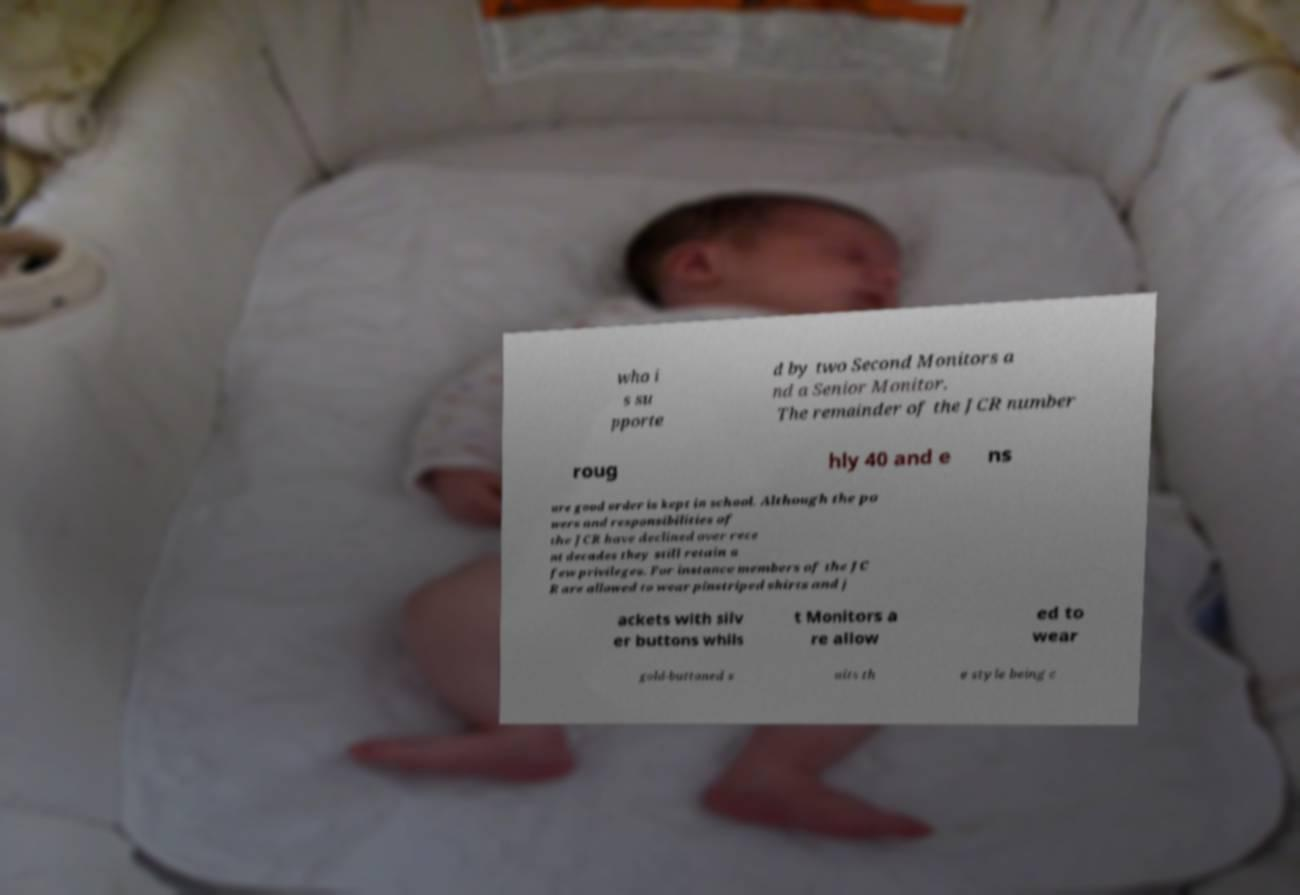What messages or text are displayed in this image? I need them in a readable, typed format. who i s su pporte d by two Second Monitors a nd a Senior Monitor. The remainder of the JCR number roug hly 40 and e ns ure good order is kept in school. Although the po wers and responsibilities of the JCR have declined over rece nt decades they still retain a few privileges. For instance members of the JC R are allowed to wear pinstriped shirts and j ackets with silv er buttons whils t Monitors a re allow ed to wear gold-buttoned s uits th e style being c 